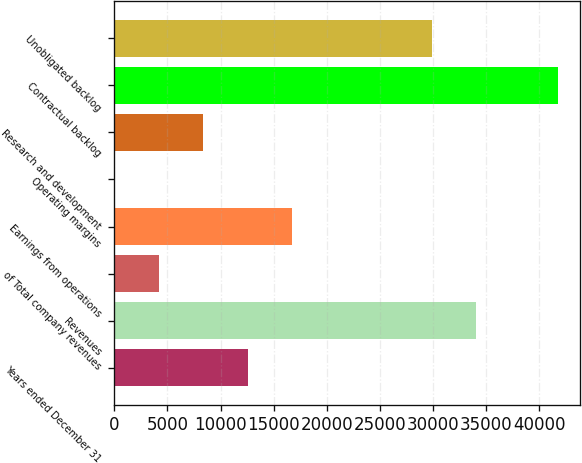Convert chart. <chart><loc_0><loc_0><loc_500><loc_500><bar_chart><fcel>Years ended December 31<fcel>Revenues<fcel>of Total company revenues<fcel>Earnings from operations<fcel>Operating margins<fcel>Research and development<fcel>Contractual backlog<fcel>Unobligated backlog<nl><fcel>12543.9<fcel>34070.7<fcel>4188.43<fcel>16721.6<fcel>10.7<fcel>8366.16<fcel>41788<fcel>29893<nl></chart> 